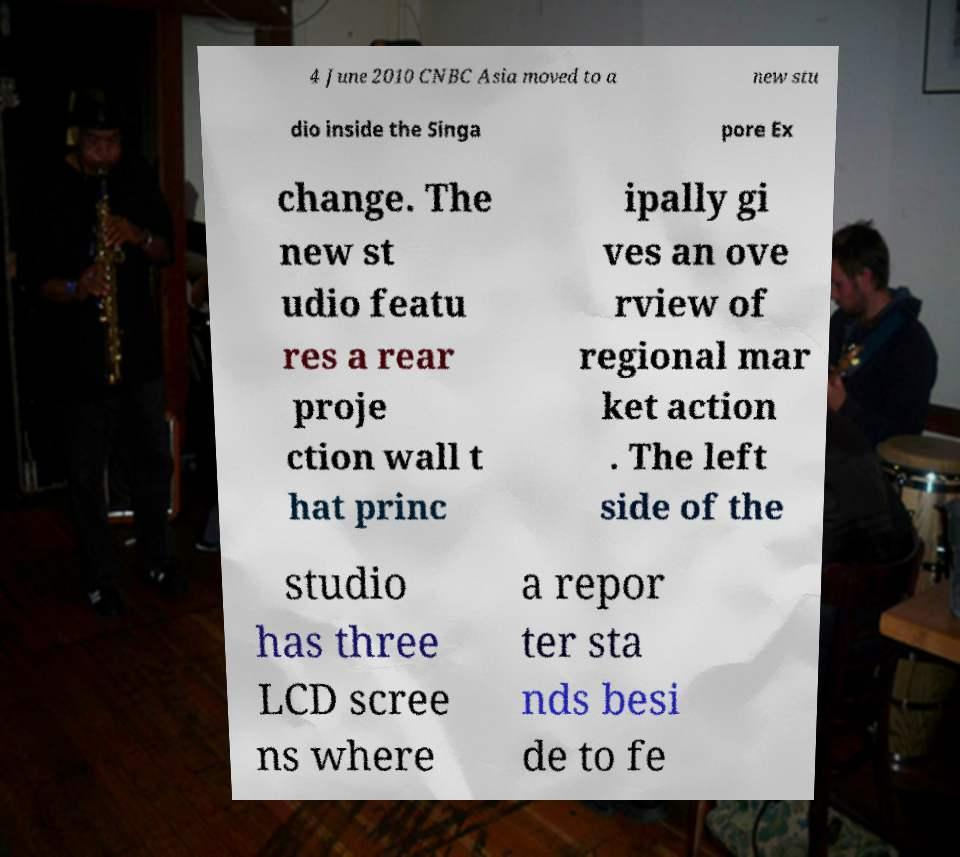Could you extract and type out the text from this image? 4 June 2010 CNBC Asia moved to a new stu dio inside the Singa pore Ex change. The new st udio featu res a rear proje ction wall t hat princ ipally gi ves an ove rview of regional mar ket action . The left side of the studio has three LCD scree ns where a repor ter sta nds besi de to fe 